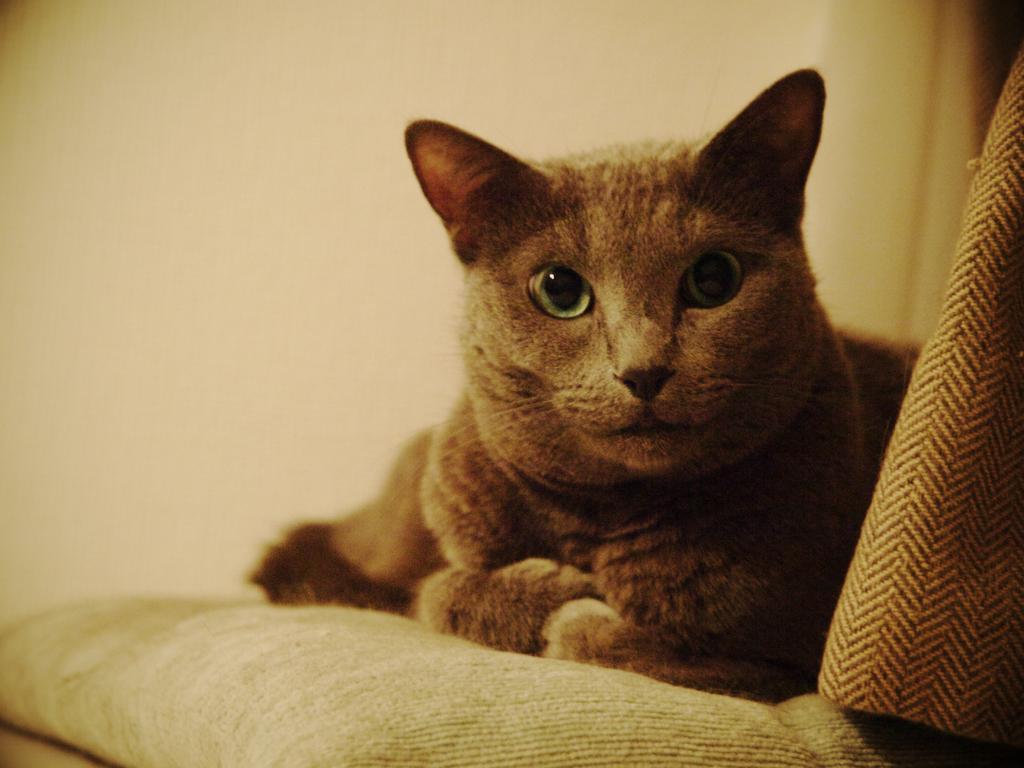Could you give a brief overview of what you see in this image? In the image there is a cat on a surface and it looks like there is a wall behind the cat. 